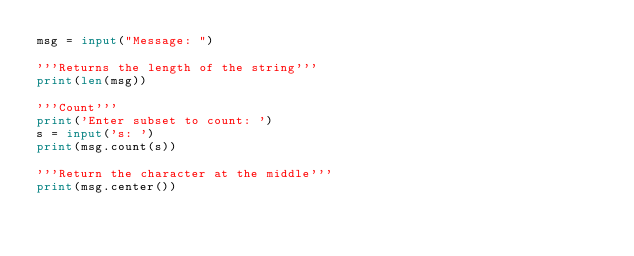<code> <loc_0><loc_0><loc_500><loc_500><_Python_>msg = input("Message: ")

'''Returns the length of the string'''
print(len(msg))

'''Count'''
print('Enter subset to count: ')
s = input('s: ')
print(msg.count(s))

'''Return the character at the middle'''
print(msg.center())</code> 